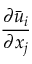Convert formula to latex. <formula><loc_0><loc_0><loc_500><loc_500>\frac { { \partial } \ B a r { u } _ { i } } { { \partial } x _ { j } }</formula> 